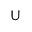Convert formula to latex. <formula><loc_0><loc_0><loc_500><loc_500>U</formula> 